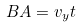Convert formula to latex. <formula><loc_0><loc_0><loc_500><loc_500>B A = v _ { y } t</formula> 